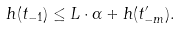<formula> <loc_0><loc_0><loc_500><loc_500>h ( t _ { - 1 } ) \leq L \cdot \alpha + h ( t ^ { \prime } _ { - m } ) .</formula> 